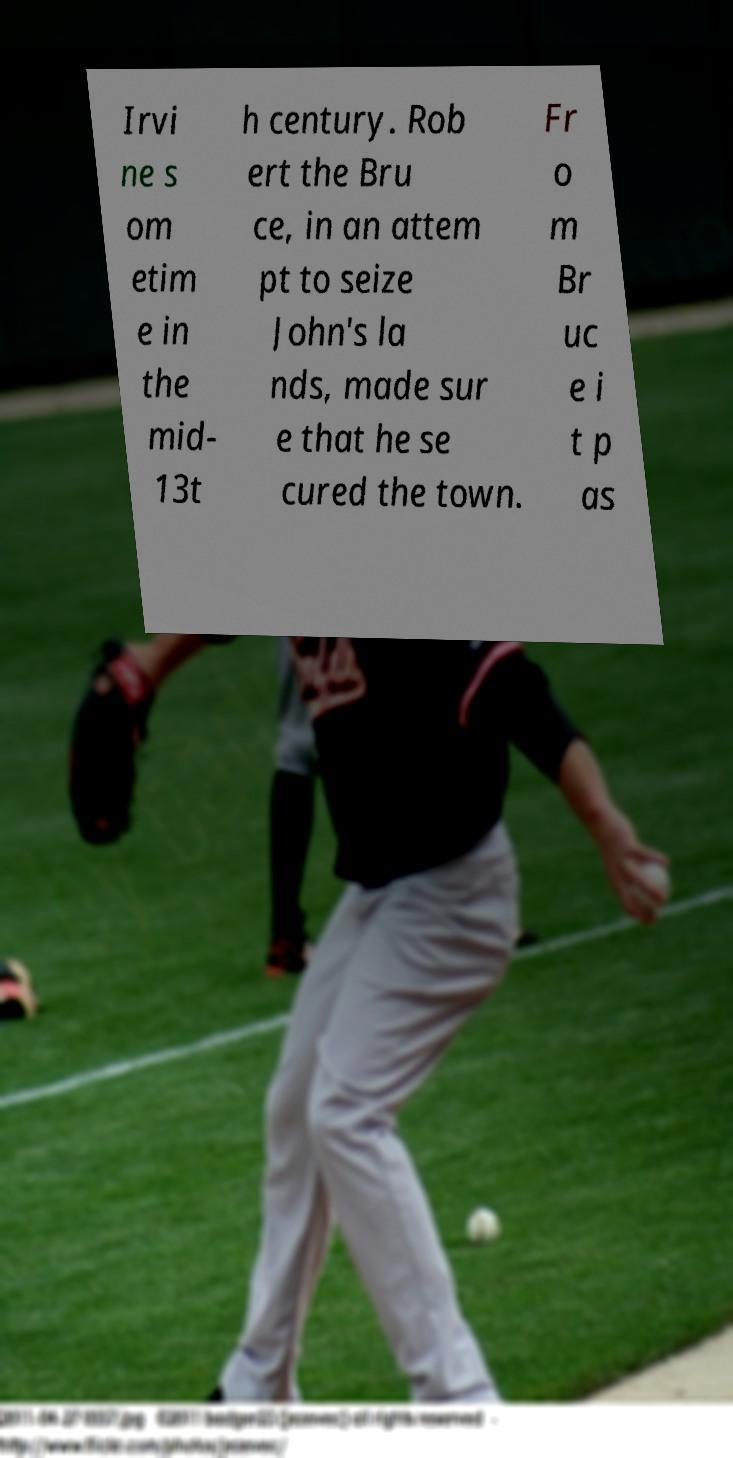Please read and relay the text visible in this image. What does it say? Irvi ne s om etim e in the mid- 13t h century. Rob ert the Bru ce, in an attem pt to seize John's la nds, made sur e that he se cured the town. Fr o m Br uc e i t p as 